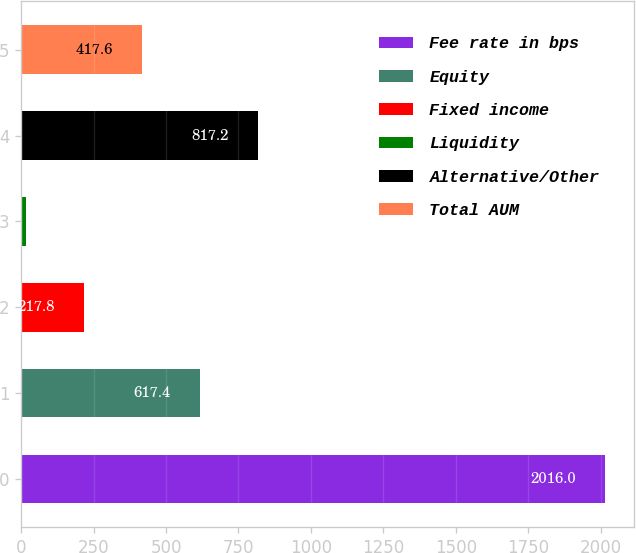Convert chart. <chart><loc_0><loc_0><loc_500><loc_500><bar_chart><fcel>Fee rate in bps<fcel>Equity<fcel>Fixed income<fcel>Liquidity<fcel>Alternative/Other<fcel>Total AUM<nl><fcel>2016<fcel>617.4<fcel>217.8<fcel>18<fcel>817.2<fcel>417.6<nl></chart> 